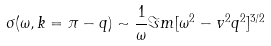Convert formula to latex. <formula><loc_0><loc_0><loc_500><loc_500>\sigma ( \omega , k = \pi - q ) \sim \frac { 1 } { \omega } \Im m [ \omega ^ { 2 } - v ^ { 2 } q ^ { 2 } ] ^ { 3 / 2 }</formula> 